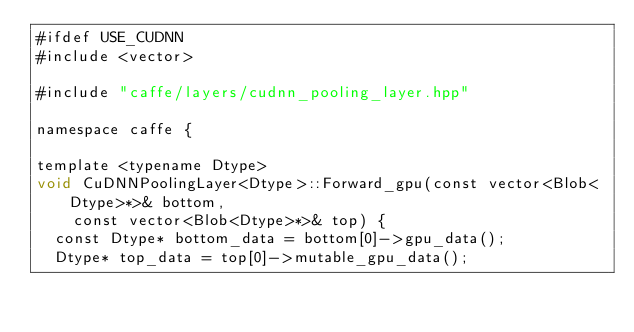<code> <loc_0><loc_0><loc_500><loc_500><_Cuda_>#ifdef USE_CUDNN
#include <vector>

#include "caffe/layers/cudnn_pooling_layer.hpp"

namespace caffe {

template <typename Dtype>
void CuDNNPoolingLayer<Dtype>::Forward_gpu(const vector<Blob<Dtype>*>& bottom,
    const vector<Blob<Dtype>*>& top) {
  const Dtype* bottom_data = bottom[0]->gpu_data();
  Dtype* top_data = top[0]->mutable_gpu_data();</code> 